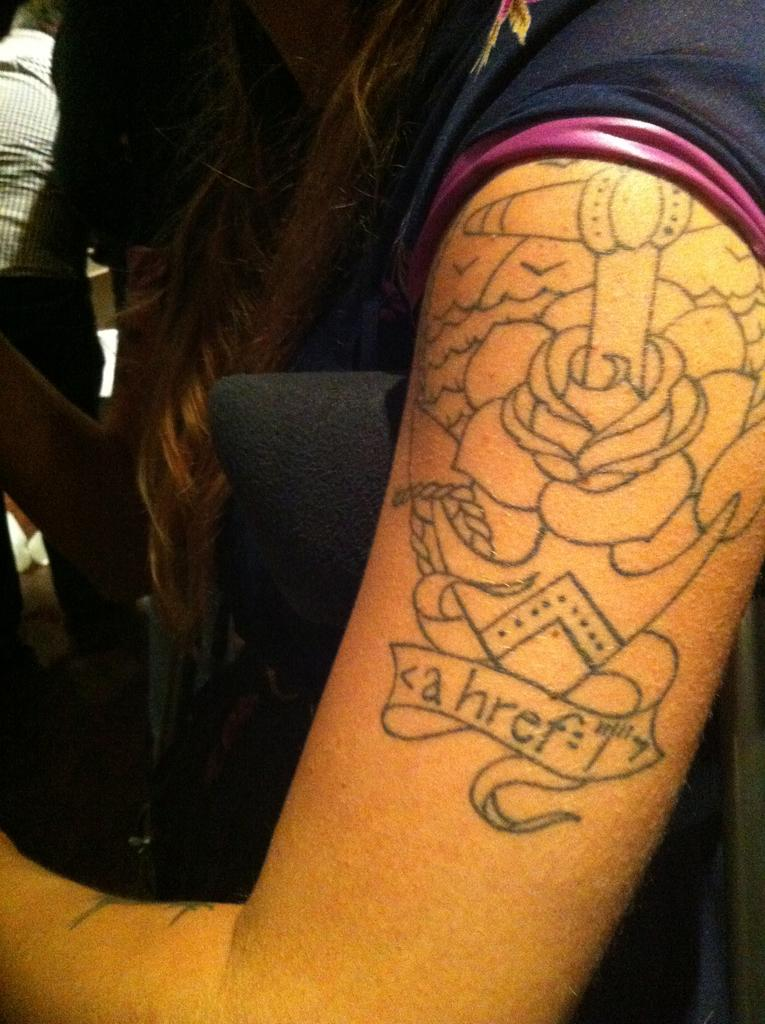Who is the main subject in the image? There is a girl in the image. What distinguishing feature can be seen on the girl's hand? The girl has a tattoo on her hand. On which side of the image is the tattoo located? The tattoo is on the right side of the image. What is the earth's tendency to rotate in the image? There is no reference to the earth or its rotation in the image, as it features a girl with a tattoo on her hand. 